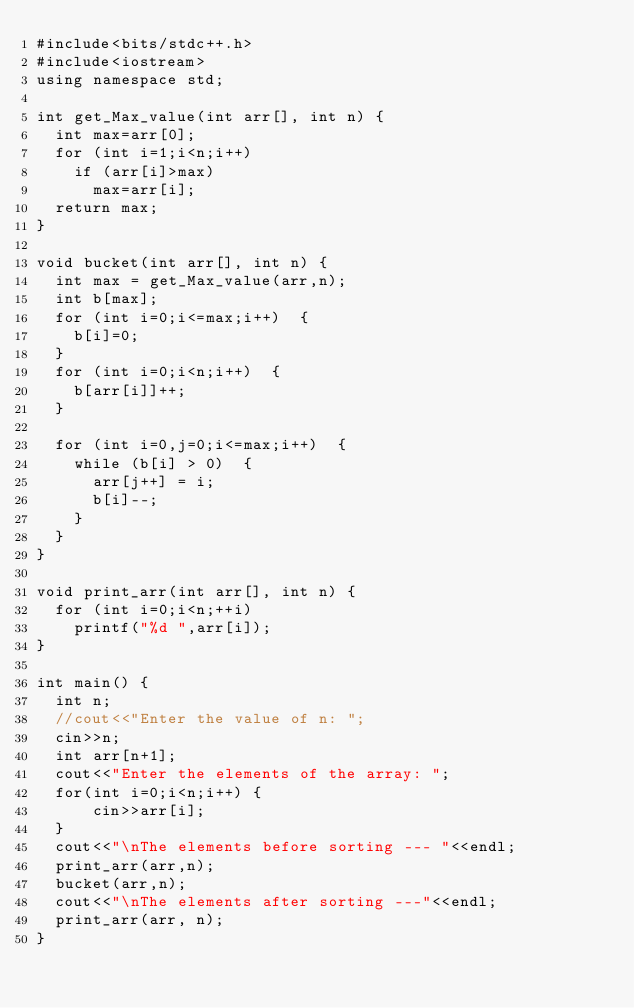<code> <loc_0><loc_0><loc_500><loc_500><_C++_>#include<bits/stdc++.h>
#include<iostream>
using namespace std;

int get_Max_value(int arr[], int n) {  
  int max=arr[0];  
  for (int i=1;i<n;i++)  
    if (arr[i]>max)  
      max=arr[i];  
  return max;  
}  

void bucket(int arr[], int n) {  
  int max = get_Max_value(arr,n);   
  int b[max];  
  for (int i=0;i<=max;i++)  {  
    b[i]=0;  
  }  
  for (int i=0;i<n;i++)  {  
    b[arr[i]]++;  
  } 

  for (int i=0,j=0;i<=max;i++)  {  
    while (b[i] > 0)  {  
      arr[j++] = i;  
      b[i]--;  
    }  
  }  
}  

void print_arr(int arr[], int n) {  
  for (int i=0;i<n;++i)  
    printf("%d ",arr[i]);  
}  

int main() {    
  int n;
  //cout<<"Enter the value of n: ";
  cin>>n;  
  int arr[n+1];
  cout<<"Enter the elements of the array: ";
  for(int i=0;i<n;i++) {
      cin>>arr[i];
  } 
  cout<<"\nThe elements before sorting --- "<<endl;
  print_arr(arr,n);  
  bucket(arr,n);  
  cout<<"\nThe elements after sorting ---"<<endl;  
  print_arr(arr, n);  
}  </code> 